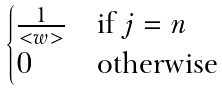<formula> <loc_0><loc_0><loc_500><loc_500>\begin{cases} \frac { 1 } { < w > } & \text {if } j = n \\ 0 & \text {otherwise} \end{cases}</formula> 